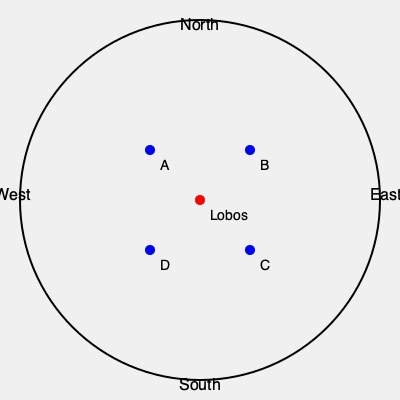Which of the marked locations (A, B, C, or D) corresponds to the historical site of Estancia San Pedro, the birthplace of Juan Domingo Perón, located approximately 15 km northwest of Lobos? To determine the correct location of Estancia San Pedro, we need to follow these steps:

1. Identify the center of the map as Lobos.
2. Understand that northwest is between north and west on the map.
3. Estimate a distance of 15 km on the scale of the map.
4. Evaluate each marked location:
   A: Northeast of Lobos
   B: Northeast of Lobos
   C: Southeast of Lobos
   D: Southwest of Lobos

5. The only location that is northwest of Lobos is point A.
6. Point A also appears to be at an appropriate distance to represent 15 km on this scale.

Therefore, point A is the most likely location for Estancia San Pedro, Juan Domingo Perón's birthplace.
Answer: A 